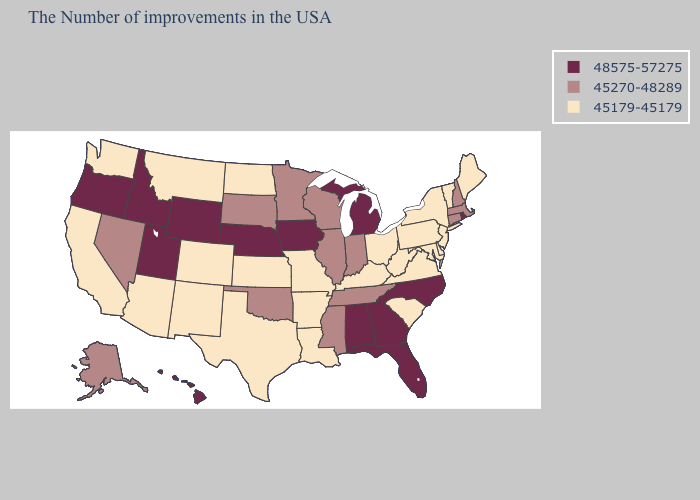Which states have the highest value in the USA?
Write a very short answer. Rhode Island, North Carolina, Florida, Georgia, Michigan, Alabama, Iowa, Nebraska, Wyoming, Utah, Idaho, Oregon, Hawaii. Name the states that have a value in the range 48575-57275?
Short answer required. Rhode Island, North Carolina, Florida, Georgia, Michigan, Alabama, Iowa, Nebraska, Wyoming, Utah, Idaho, Oregon, Hawaii. Among the states that border Ohio , which have the lowest value?
Short answer required. Pennsylvania, West Virginia, Kentucky. Is the legend a continuous bar?
Concise answer only. No. What is the value of New Jersey?
Be succinct. 45179-45179. Name the states that have a value in the range 48575-57275?
Be succinct. Rhode Island, North Carolina, Florida, Georgia, Michigan, Alabama, Iowa, Nebraska, Wyoming, Utah, Idaho, Oregon, Hawaii. Which states have the lowest value in the MidWest?
Give a very brief answer. Ohio, Missouri, Kansas, North Dakota. Name the states that have a value in the range 48575-57275?
Be succinct. Rhode Island, North Carolina, Florida, Georgia, Michigan, Alabama, Iowa, Nebraska, Wyoming, Utah, Idaho, Oregon, Hawaii. Name the states that have a value in the range 45179-45179?
Quick response, please. Maine, Vermont, New York, New Jersey, Delaware, Maryland, Pennsylvania, Virginia, South Carolina, West Virginia, Ohio, Kentucky, Louisiana, Missouri, Arkansas, Kansas, Texas, North Dakota, Colorado, New Mexico, Montana, Arizona, California, Washington. What is the highest value in the South ?
Answer briefly. 48575-57275. Among the states that border Alabama , does Georgia have the highest value?
Short answer required. Yes. What is the highest value in the USA?
Concise answer only. 48575-57275. Name the states that have a value in the range 45270-48289?
Answer briefly. Massachusetts, New Hampshire, Connecticut, Indiana, Tennessee, Wisconsin, Illinois, Mississippi, Minnesota, Oklahoma, South Dakota, Nevada, Alaska. What is the lowest value in states that border Illinois?
Give a very brief answer. 45179-45179. What is the value of Arkansas?
Answer briefly. 45179-45179. 